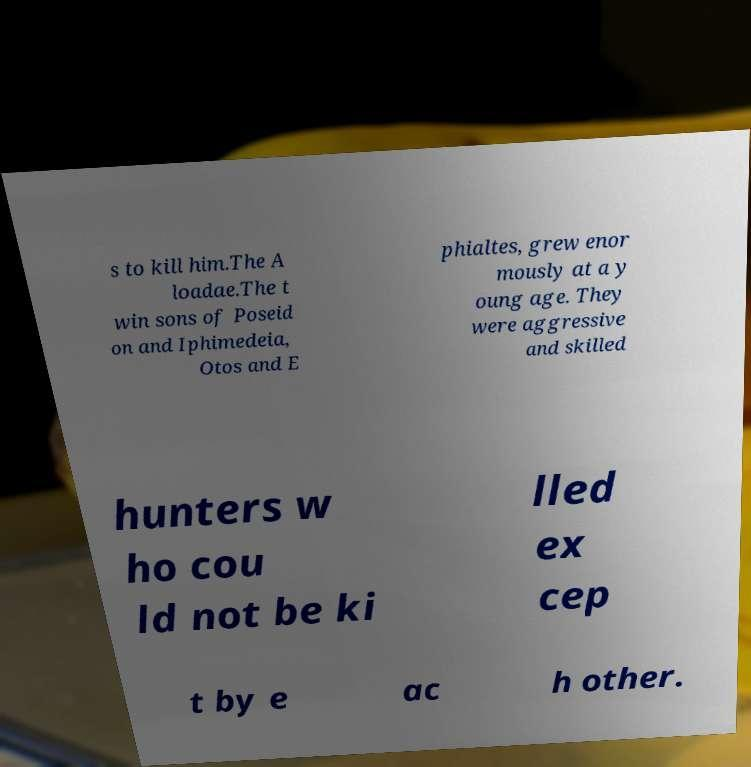What messages or text are displayed in this image? I need them in a readable, typed format. s to kill him.The A loadae.The t win sons of Poseid on and Iphimedeia, Otos and E phialtes, grew enor mously at a y oung age. They were aggressive and skilled hunters w ho cou ld not be ki lled ex cep t by e ac h other. 